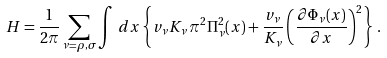Convert formula to latex. <formula><loc_0><loc_0><loc_500><loc_500>H = \frac { 1 } { 2 \pi } \sum _ { \nu = \rho , \sigma } \int \, d x \left \{ v _ { \nu } K _ { \nu } \, \pi ^ { 2 } \Pi _ { \nu } ^ { 2 } ( x ) + \frac { v _ { \nu } } { K _ { \nu } } \left ( \frac { \partial \Phi _ { \nu } ( x ) } { \partial x } \right ) ^ { 2 } \right \} \, .</formula> 